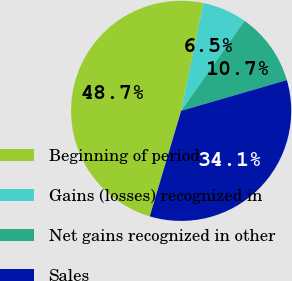<chart> <loc_0><loc_0><loc_500><loc_500><pie_chart><fcel>Beginning of period<fcel>Gains (losses) recognized in<fcel>Net gains recognized in other<fcel>Sales<nl><fcel>48.65%<fcel>6.52%<fcel>10.73%<fcel>34.1%<nl></chart> 